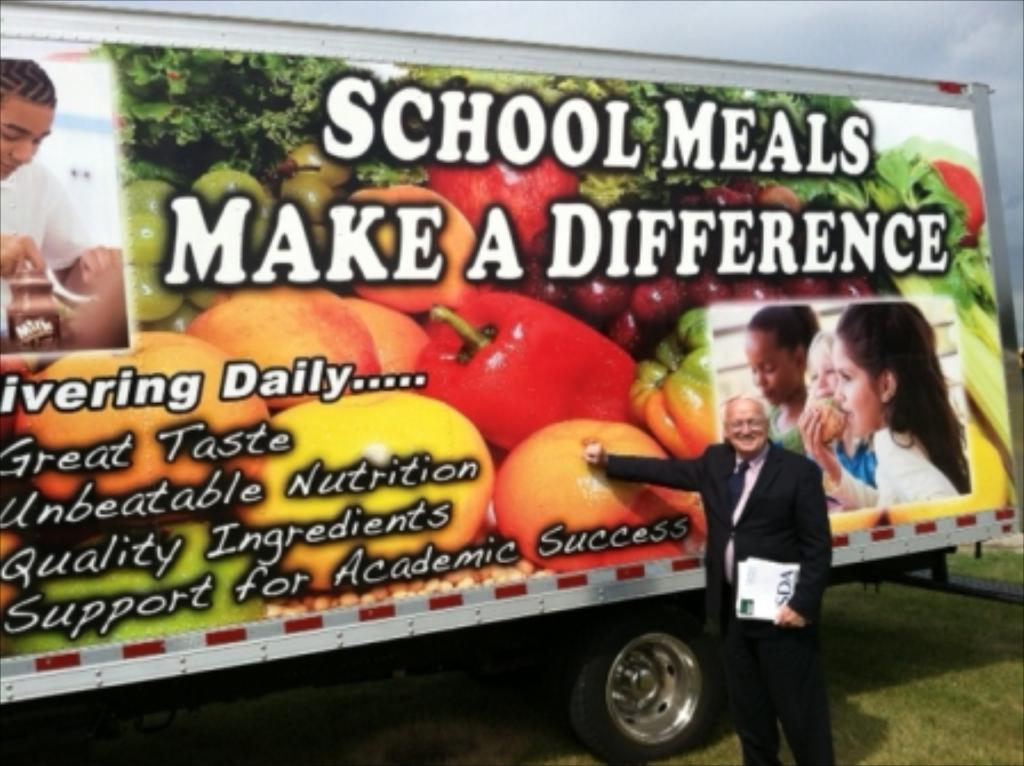What is the main subject in the image? There is a vehicle in the image. What else can be seen in the image besides the vehicle? There is an advertisement and a person visible in the image. What type of natural environment is present in the image? There is grass in the image. What is visible in the background of the image? The sky is visible in the background of the image. What is the aftermath of the son's eye injury in the image? There is no reference to a son or an eye injury in the image, so it is not possible to determine the aftermath of such an event. 